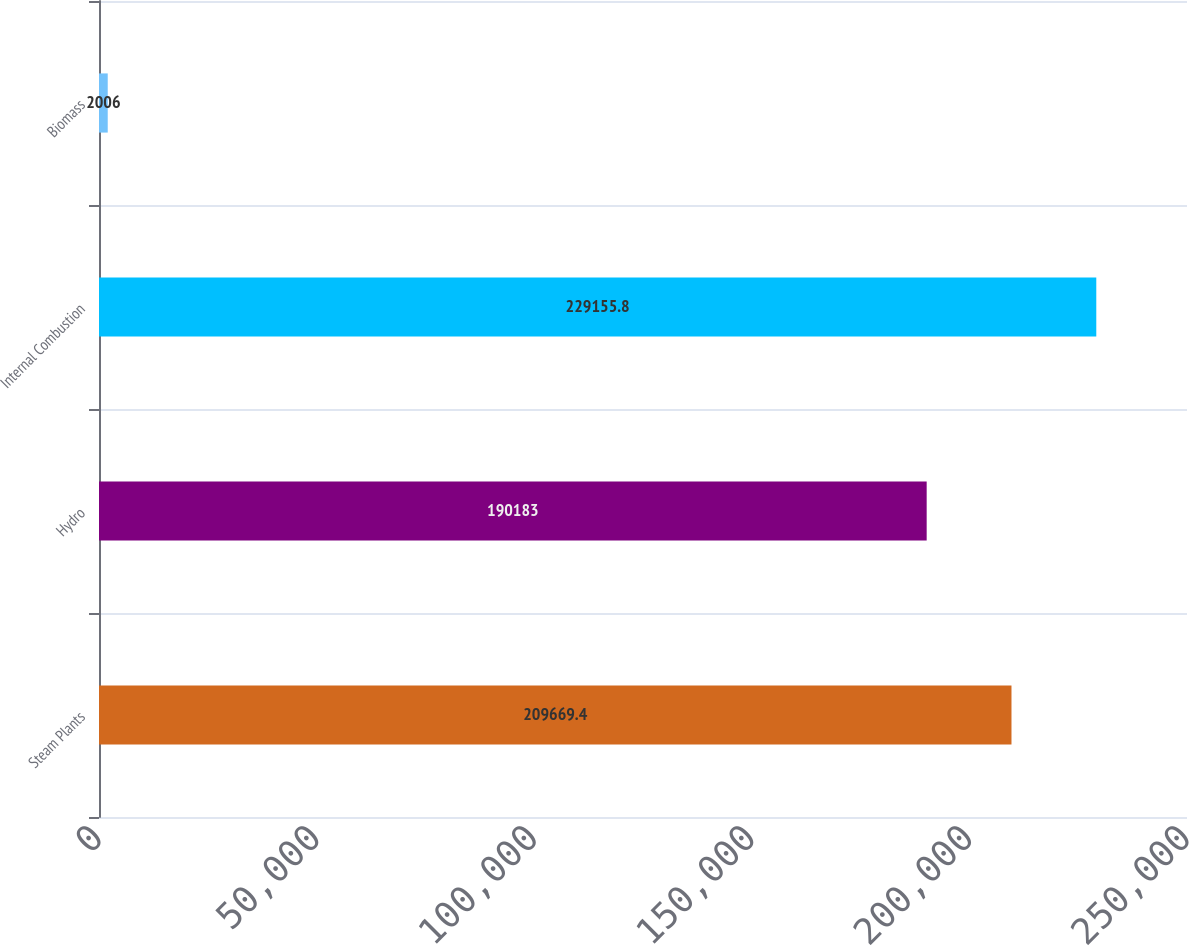<chart> <loc_0><loc_0><loc_500><loc_500><bar_chart><fcel>Steam Plants<fcel>Hydro<fcel>Internal Combustion<fcel>Biomass<nl><fcel>209669<fcel>190183<fcel>229156<fcel>2006<nl></chart> 